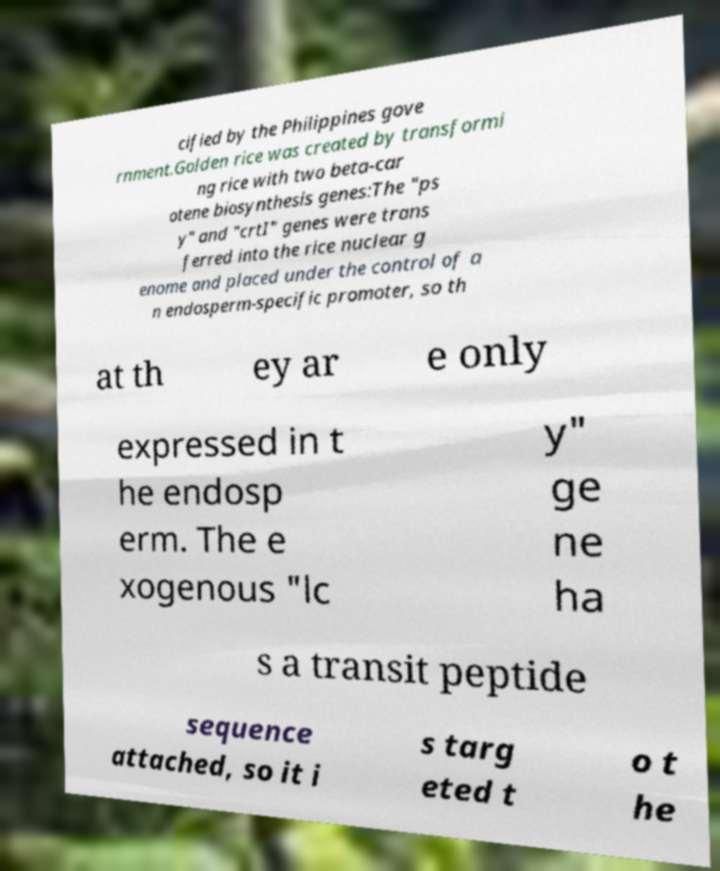What messages or text are displayed in this image? I need them in a readable, typed format. cified by the Philippines gove rnment.Golden rice was created by transformi ng rice with two beta-car otene biosynthesis genes:The "ps y" and "crtI" genes were trans ferred into the rice nuclear g enome and placed under the control of a n endosperm-specific promoter, so th at th ey ar e only expressed in t he endosp erm. The e xogenous "lc y" ge ne ha s a transit peptide sequence attached, so it i s targ eted t o t he 